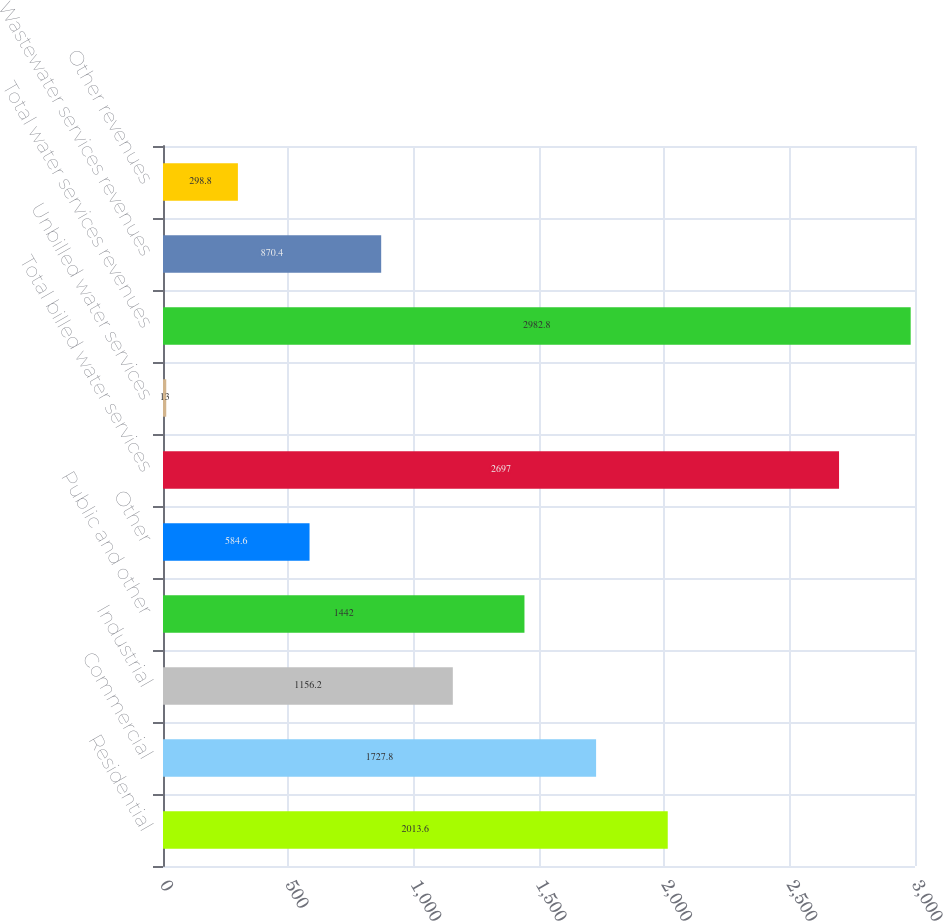Convert chart to OTSL. <chart><loc_0><loc_0><loc_500><loc_500><bar_chart><fcel>Residential<fcel>Commercial<fcel>Industrial<fcel>Public and other<fcel>Other<fcel>Total billed water services<fcel>Unbilled water services<fcel>Total water services revenues<fcel>Wastewater services revenues<fcel>Other revenues<nl><fcel>2013.6<fcel>1727.8<fcel>1156.2<fcel>1442<fcel>584.6<fcel>2697<fcel>13<fcel>2982.8<fcel>870.4<fcel>298.8<nl></chart> 